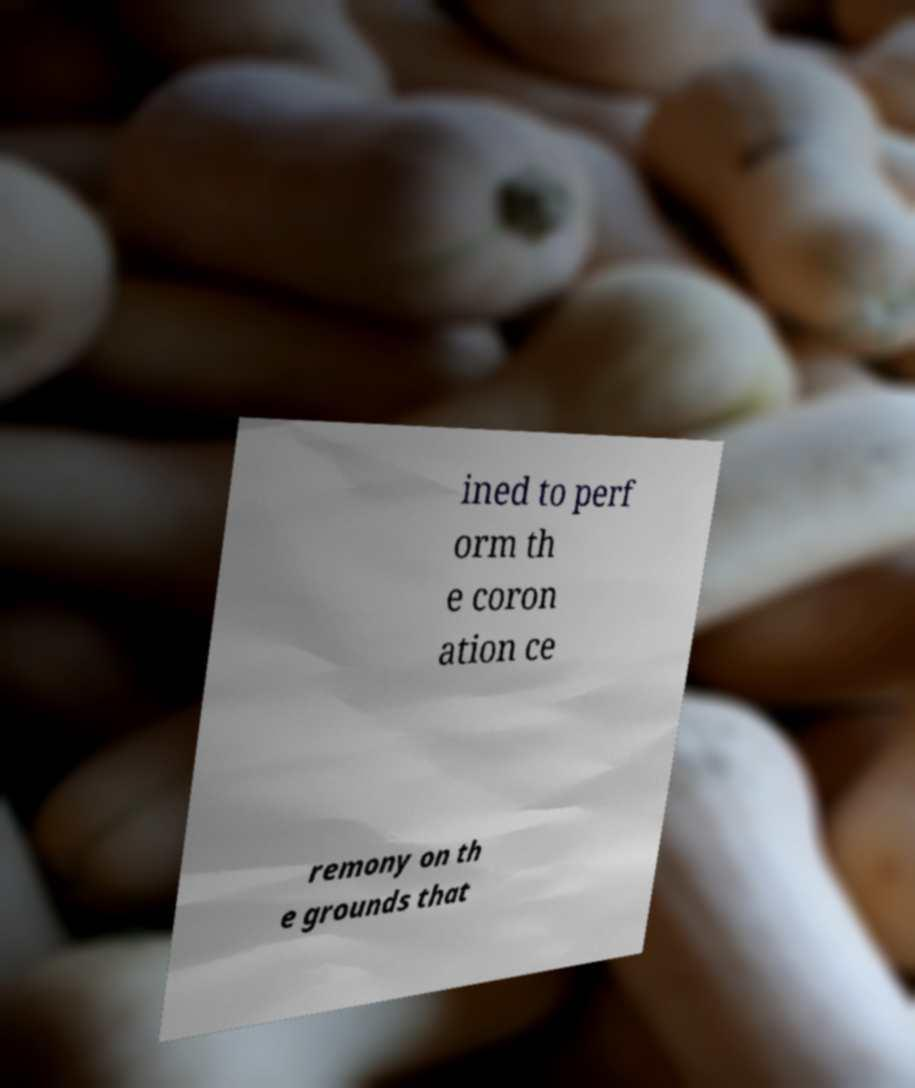Could you extract and type out the text from this image? ined to perf orm th e coron ation ce remony on th e grounds that 